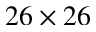Convert formula to latex. <formula><loc_0><loc_0><loc_500><loc_500>2 6 \times 2 6</formula> 